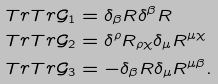Convert formula to latex. <formula><loc_0><loc_0><loc_500><loc_500>T r T r \mathcal { G } _ { 1 } & = \delta _ { \beta } R \delta ^ { \beta } R \\ T r T r \mathcal { G } _ { 2 } & = \delta ^ { \rho } R _ { \rho \chi } \delta _ { \mu } R ^ { \mu \chi } \\ T r T r \mathcal { G } _ { 3 } & = - \delta _ { \beta } R \delta _ { \mu } R ^ { \mu \beta } .</formula> 